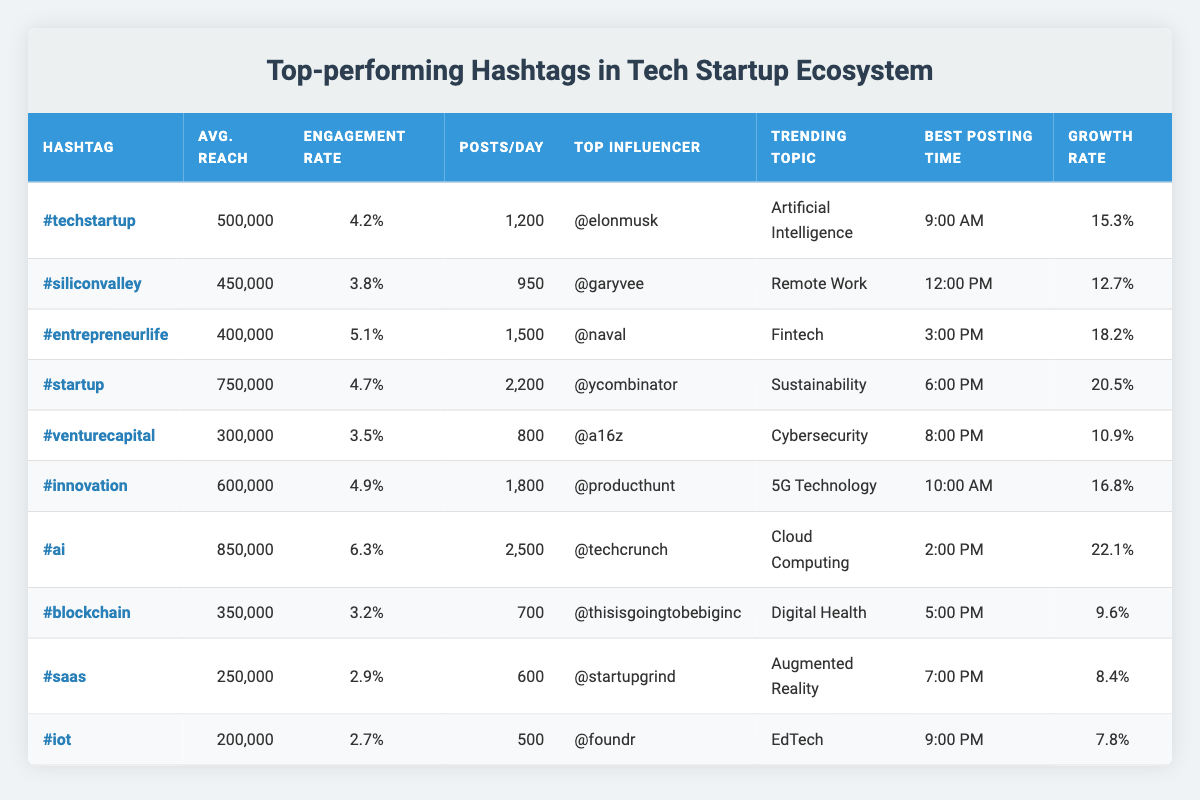What is the average reach of the hashtag #ai? Looking at the table under the 'Avg. Reach' column, for the hashtag #ai, the value is listed as 850000.
Answer: 850000 Which hashtag has the highest engagement rate? By reviewing the 'Engagement Rate' column, the hashtag with the highest value is #ai, which has an engagement rate of 6.3%.
Answer: #ai How many total posts per day are made using the hashtags listed in the table? To find the total number of posts per day, sum all the values under the 'Posts/Day' column: 1200 + 950 + 1500 + 2200 + 800 + 1800 + 2500 + 700 + 600 + 500 = 17600.
Answer: 17600 Is the growth rate for #venturecapital more than 15%? Looking at the 'Growth Rate' column for #venturecapital, the value is 10.9%, which is less than 15%. Thus, the answer is no.
Answer: No Which hashtag has the best posting time, and what is that time? In the 'Best Posting Time' column, the first row lists #techstartup with the time 9:00 AM, indicating it is the best time listed.
Answer: #techstartup at 9:00 AM What is the average engagement rate for hashtags with an average reach above 500,000? First, identify the hashtags with an average reach above 500,000: #techstartup, #innovation, #ai. The engagement rates are 4.2%, 4.9%, and 6.3%. Sum these rates: 4.2 + 4.9 + 6.3 = 15.4%. Then, divide by 3 (the number of hashtags): 15.4% / 3 = 5.13%.
Answer: 5.13% Which hashtag has the lowest number of posts per day, and how many are there? Reviewing the 'Posts/Day' column, the hashtag with the lowest value is #foundr with 500 posts per day.
Answer: #foundr with 500 posts Is there any influencer listed under #blockchain? The table shows the top influencer for #blockchain is @techcrunch, which confirms that there is an influencer listed.
Answer: Yes What is the difference between the average reach of #startup and #iot? Looking at the 'Avg. Reach' values, #startup has 750000 and #iot has 250000. The difference is calculated as 750000 - 250000 = 500000.
Answer: 500000 What are the trending topics associated with hashtags that have an engagement rate above 5%? The hashtags with engagement rates above 5% are #ai and #entrepreneurlife. Their corresponding trending topics are "Artificial Intelligence" and "Fintech."
Answer: Artificial Intelligence and Fintech Which hashtag experienced the smallest growth rate last month and what was that rate? From the 'Growth Rate' column, the hashtag with the smallest growth is #foundr at 7.8%.
Answer: #foundr with 7.8% 